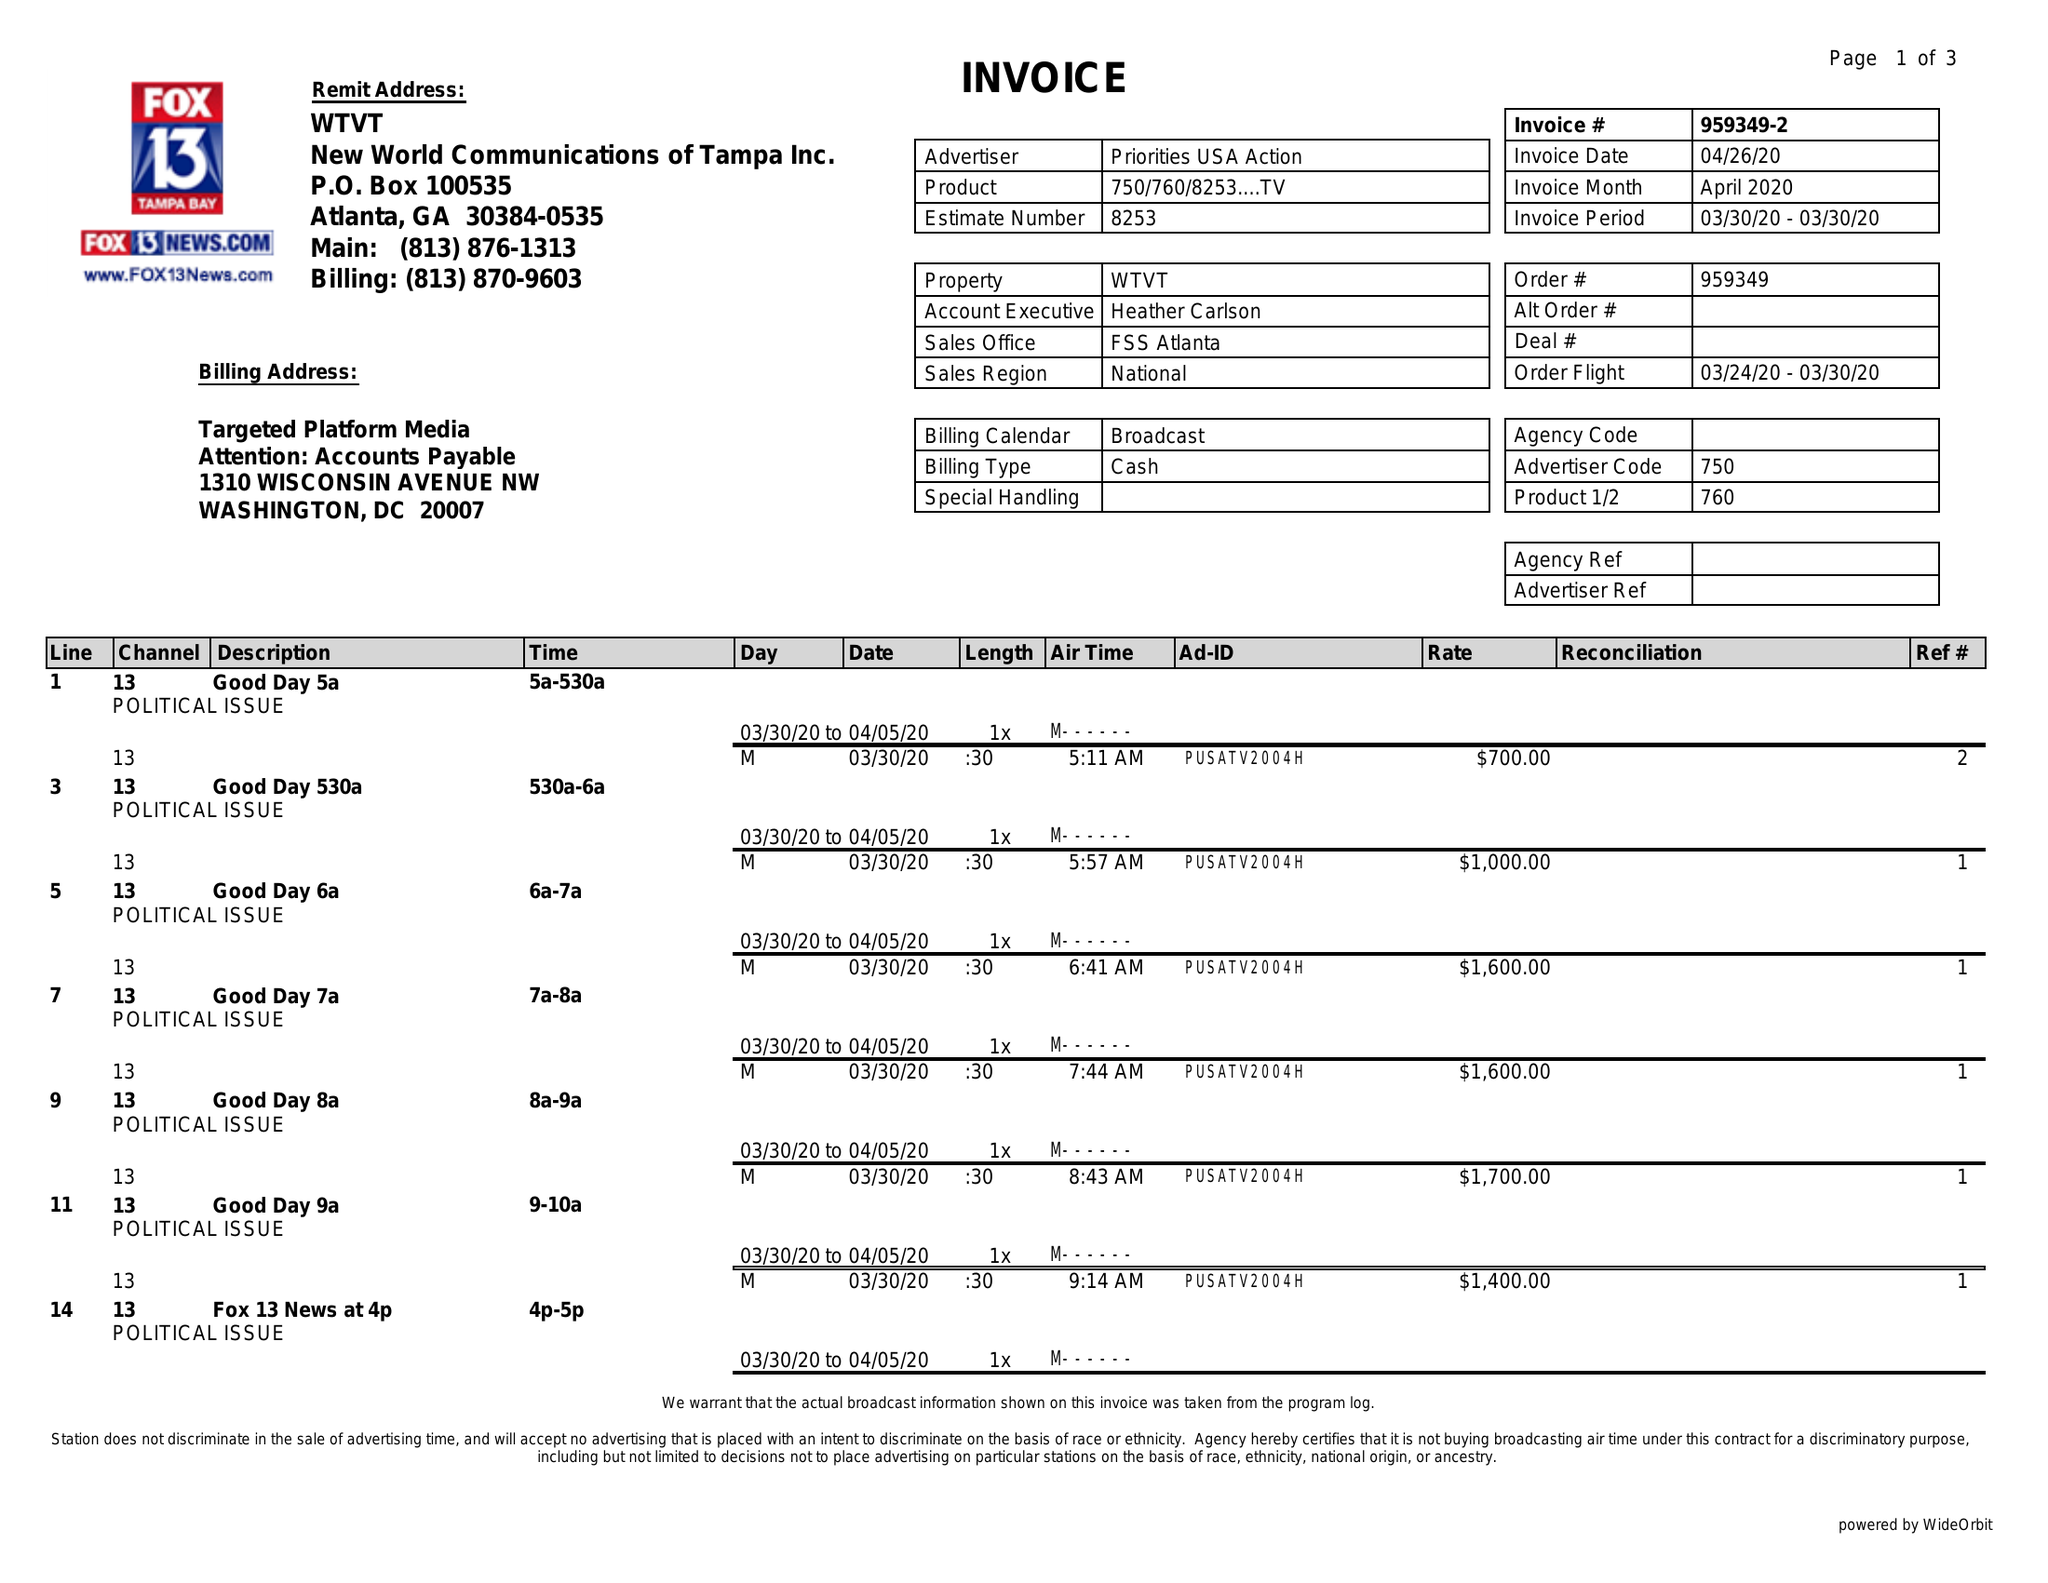What is the value for the flight_from?
Answer the question using a single word or phrase. 03/24/20 